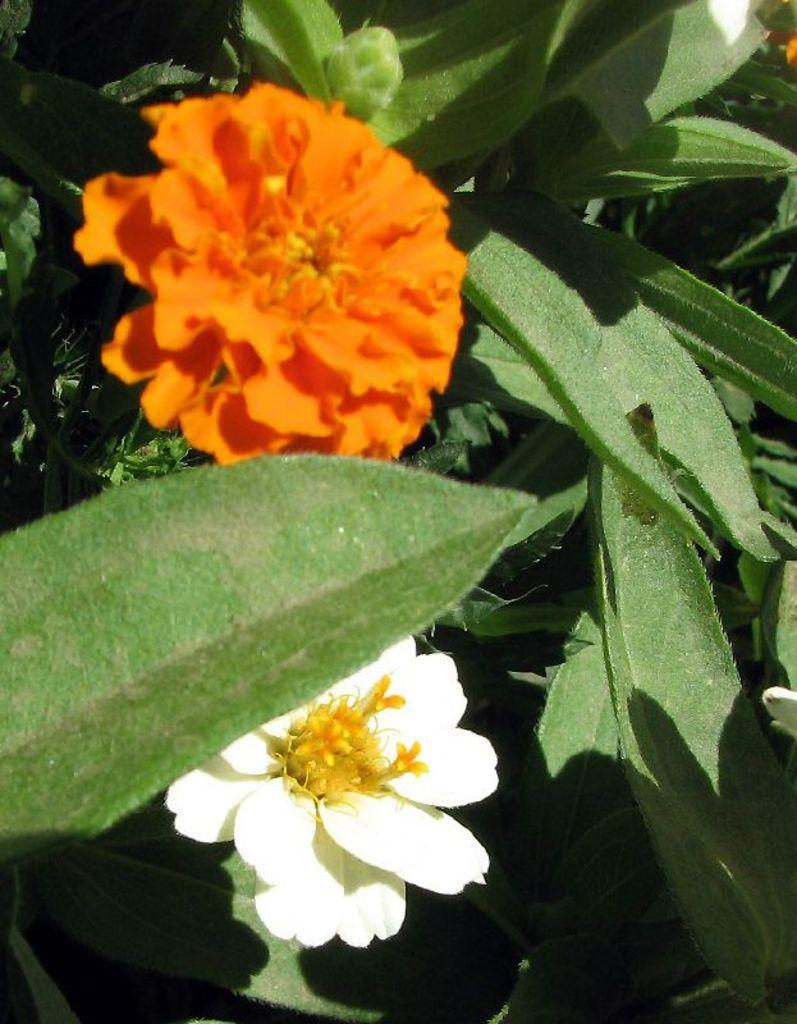What is present in the image? There are flowers in the image. What are the flowers doing or being used for? The flowers are presented to plants. What type of fuel is being used by the flowers in the image? There is no mention of fuel in the image, as it features flowers presented to plants. 